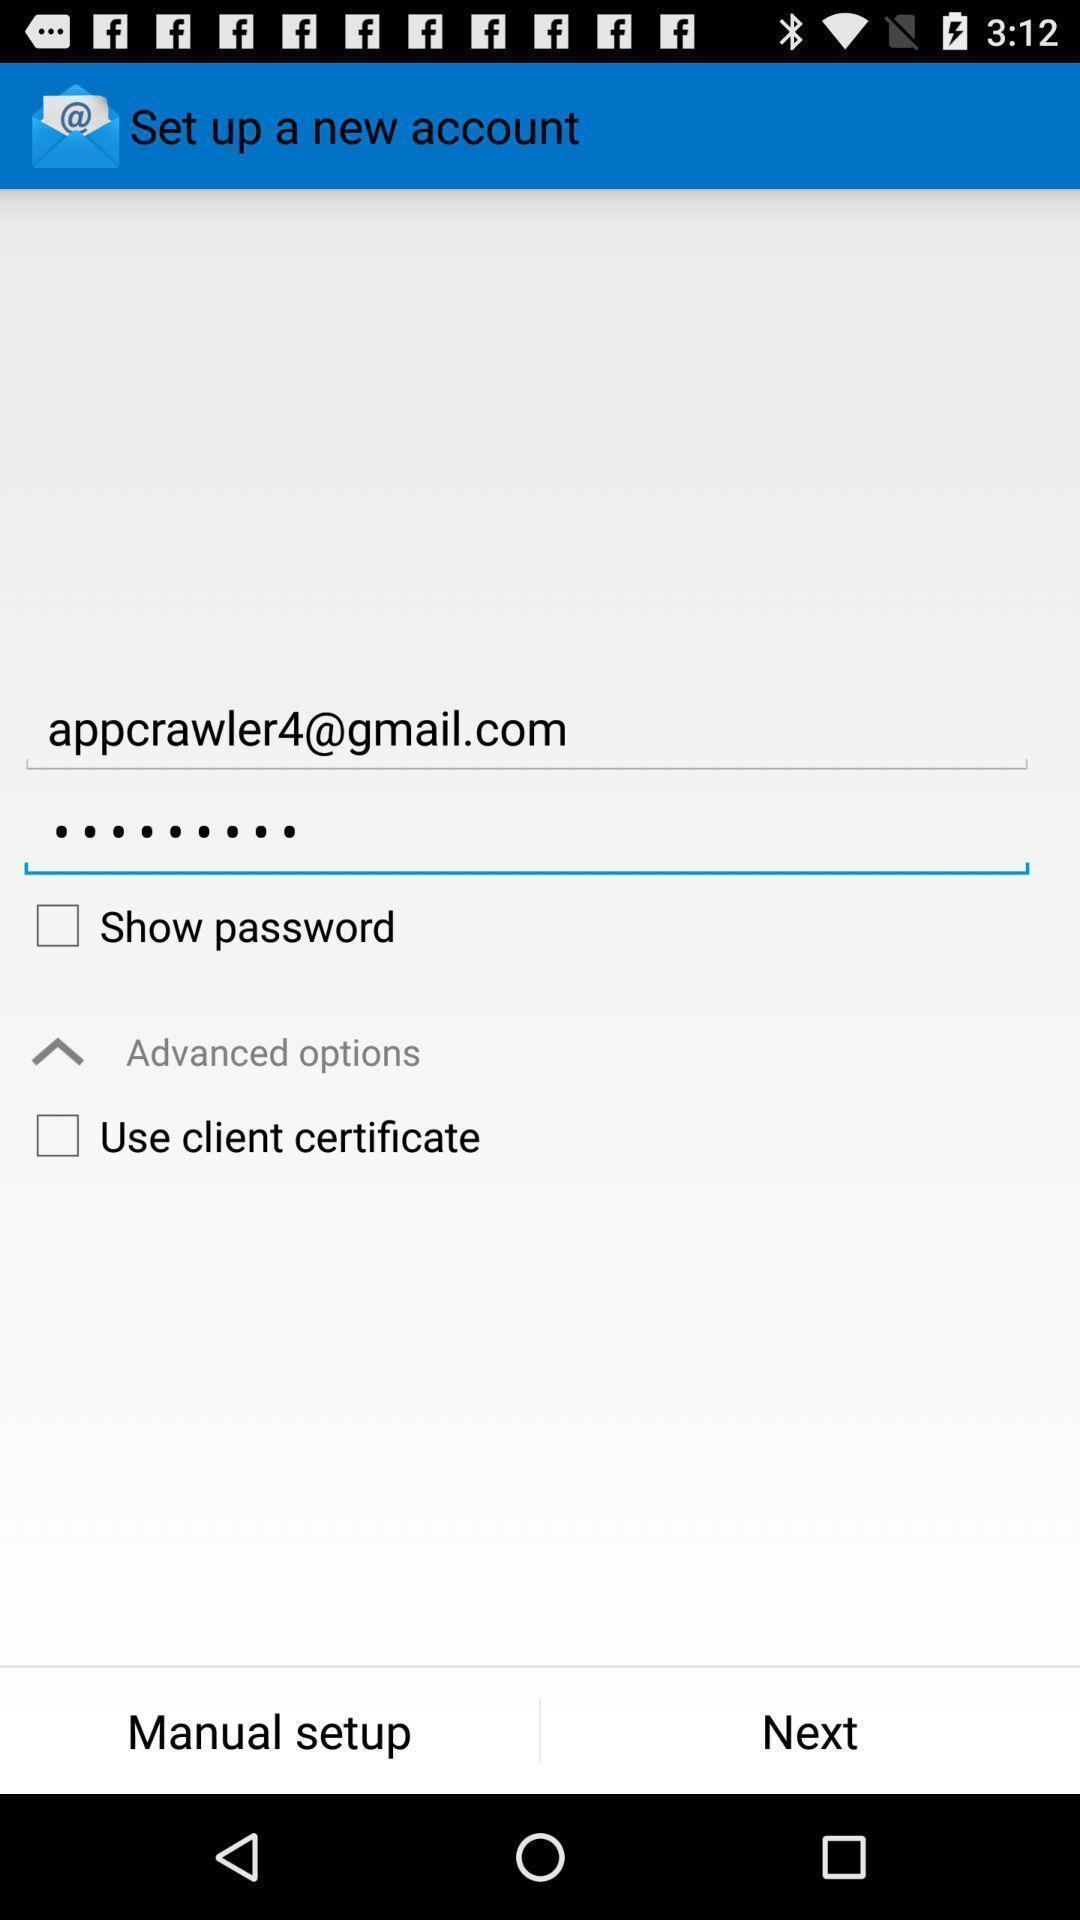Summarize the information in this screenshot. Setup page of an account for an app. 